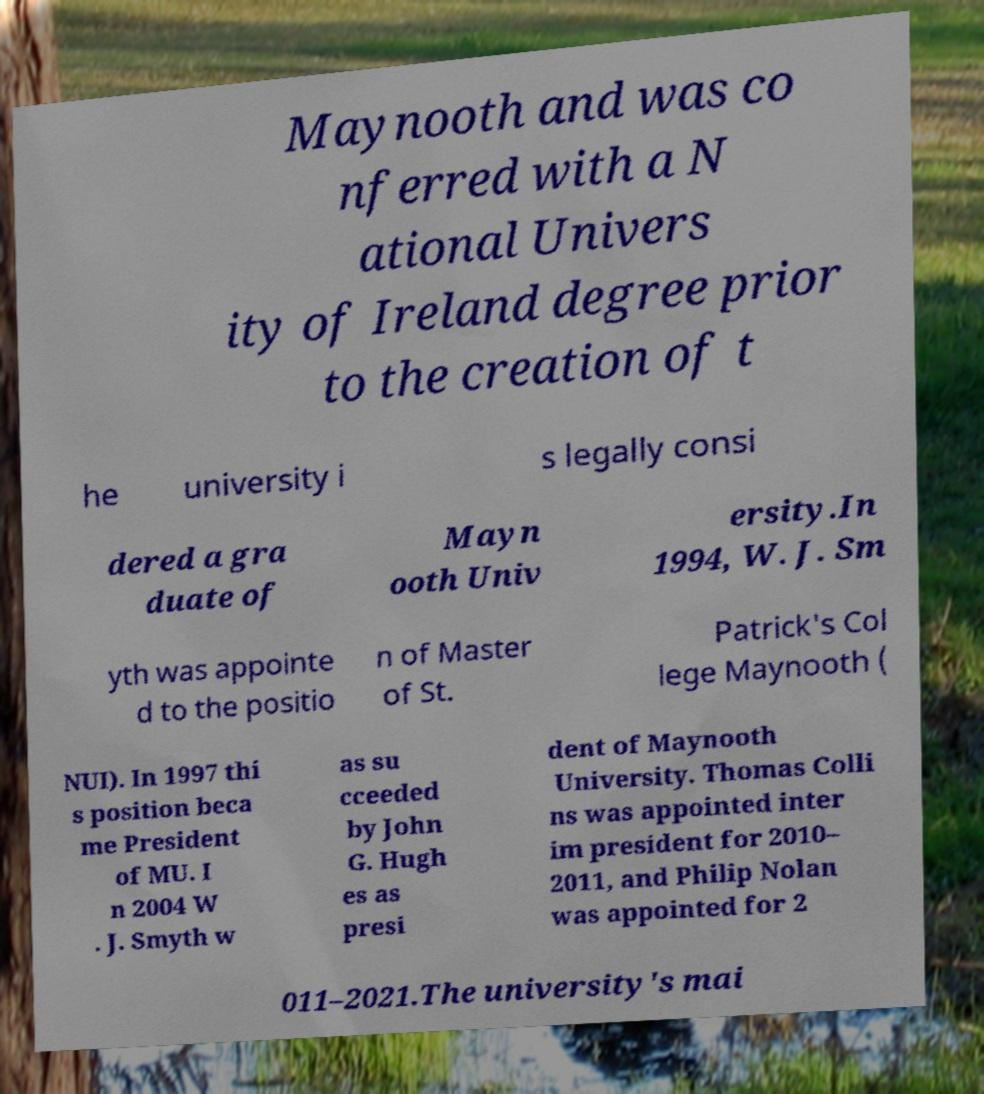What messages or text are displayed in this image? I need them in a readable, typed format. Maynooth and was co nferred with a N ational Univers ity of Ireland degree prior to the creation of t he university i s legally consi dered a gra duate of Mayn ooth Univ ersity.In 1994, W. J. Sm yth was appointe d to the positio n of Master of St. Patrick's Col lege Maynooth ( NUI). In 1997 thi s position beca me President of MU. I n 2004 W . J. Smyth w as su cceeded by John G. Hugh es as presi dent of Maynooth University. Thomas Colli ns was appointed inter im president for 2010– 2011, and Philip Nolan was appointed for 2 011–2021.The university's mai 